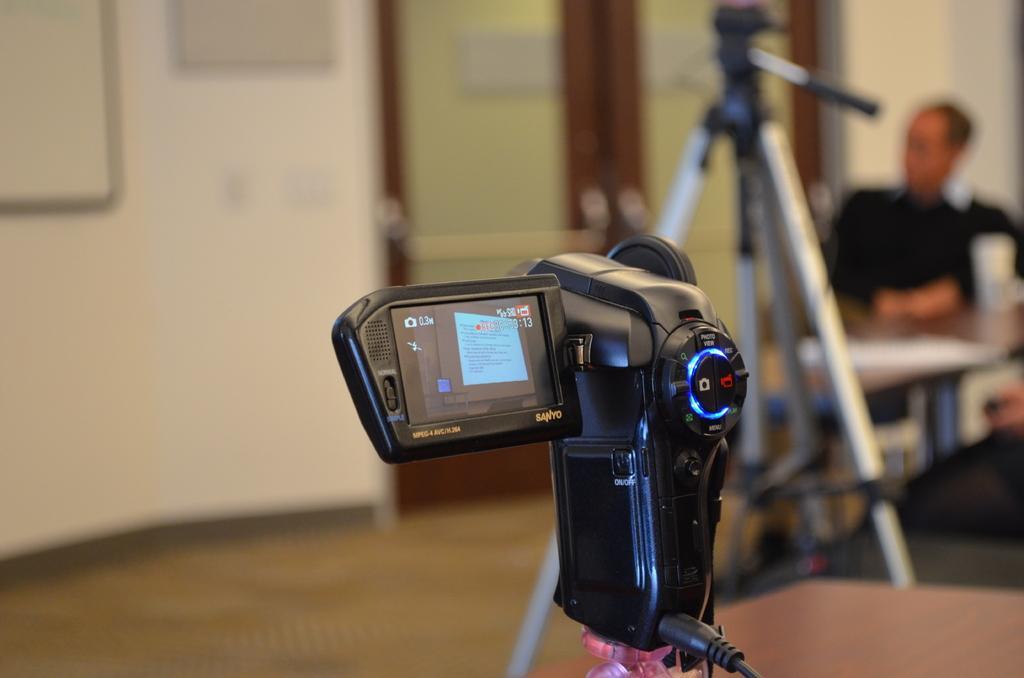Could you give a brief overview of what you see in this image? In this image, I can see a camcorder. On the right side of the image, there is a tripod stand, door and a person sitting. On the left side of the image, I can see boards attached to the wall. 